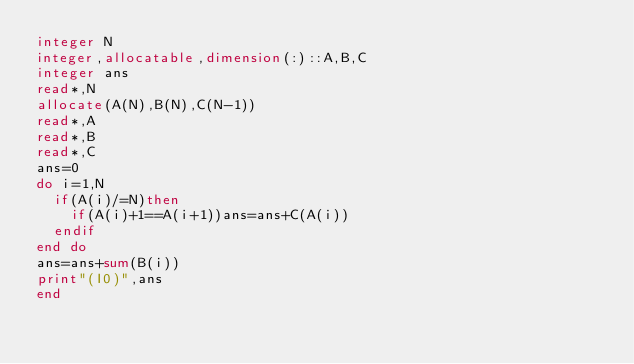Convert code to text. <code><loc_0><loc_0><loc_500><loc_500><_FORTRAN_>integer N
integer,allocatable,dimension(:)::A,B,C
integer ans
read*,N
allocate(A(N),B(N),C(N-1))
read*,A
read*,B
read*,C
ans=0
do i=1,N
  if(A(i)/=N)then
    if(A(i)+1==A(i+1))ans=ans+C(A(i))
  endif
end do
ans=ans+sum(B(i))
print"(I0)",ans
end</code> 